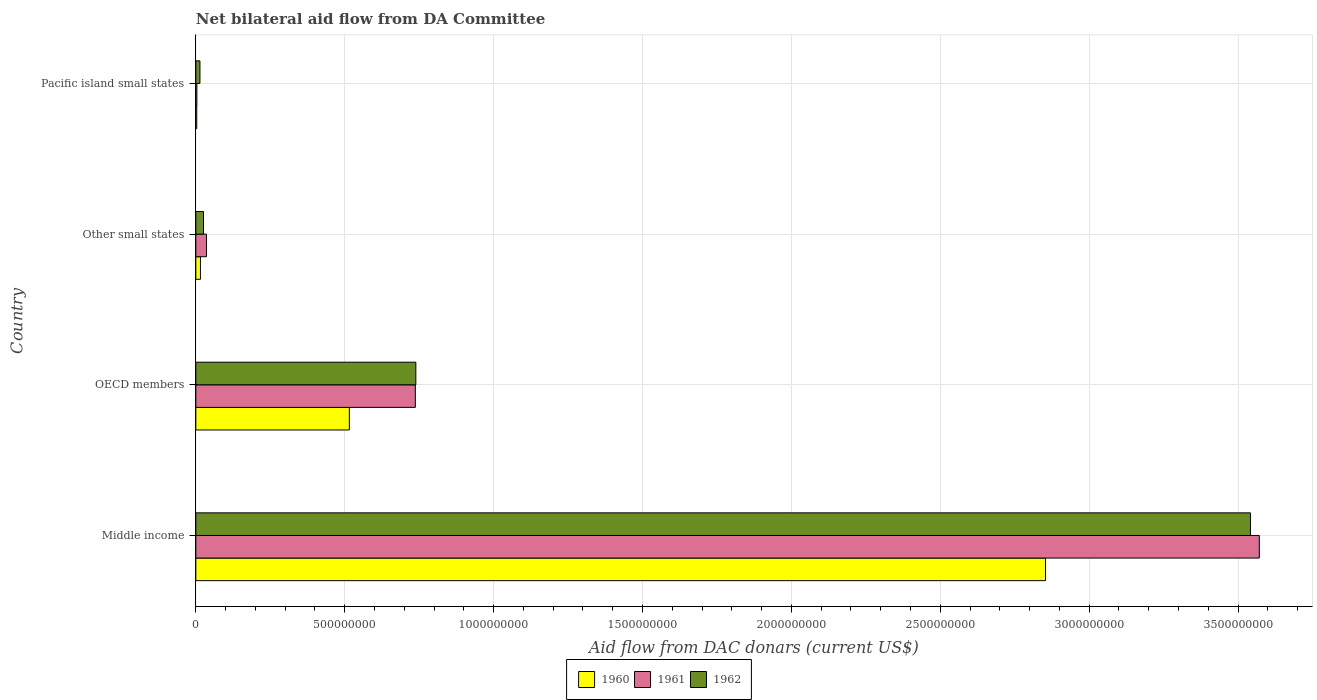How many bars are there on the 2nd tick from the top?
Make the answer very short. 3. How many bars are there on the 4th tick from the bottom?
Your response must be concise. 3. What is the label of the 2nd group of bars from the top?
Keep it short and to the point. Other small states. In how many cases, is the number of bars for a given country not equal to the number of legend labels?
Offer a terse response. 0. What is the aid flow in in 1960 in Middle income?
Offer a very short reply. 2.85e+09. Across all countries, what is the maximum aid flow in in 1960?
Provide a short and direct response. 2.85e+09. Across all countries, what is the minimum aid flow in in 1962?
Provide a short and direct response. 1.38e+07. In which country was the aid flow in in 1960 maximum?
Keep it short and to the point. Middle income. In which country was the aid flow in in 1961 minimum?
Make the answer very short. Pacific island small states. What is the total aid flow in in 1962 in the graph?
Give a very brief answer. 4.32e+09. What is the difference between the aid flow in in 1960 in Other small states and that in Pacific island small states?
Make the answer very short. 1.24e+07. What is the difference between the aid flow in in 1960 in Pacific island small states and the aid flow in in 1961 in Other small states?
Keep it short and to the point. -3.26e+07. What is the average aid flow in in 1961 per country?
Ensure brevity in your answer.  1.09e+09. What is the difference between the aid flow in in 1962 and aid flow in in 1961 in OECD members?
Give a very brief answer. 1.69e+06. What is the ratio of the aid flow in in 1962 in Middle income to that in OECD members?
Offer a terse response. 4.79. Is the aid flow in in 1960 in Other small states less than that in Pacific island small states?
Keep it short and to the point. No. What is the difference between the highest and the second highest aid flow in in 1962?
Offer a terse response. 2.80e+09. What is the difference between the highest and the lowest aid flow in in 1961?
Ensure brevity in your answer.  3.57e+09. In how many countries, is the aid flow in in 1960 greater than the average aid flow in in 1960 taken over all countries?
Your answer should be compact. 1. What does the 1st bar from the top in Middle income represents?
Your response must be concise. 1962. Is it the case that in every country, the sum of the aid flow in in 1962 and aid flow in in 1961 is greater than the aid flow in in 1960?
Ensure brevity in your answer.  Yes. How many bars are there?
Keep it short and to the point. 12. How many countries are there in the graph?
Offer a very short reply. 4. What is the difference between two consecutive major ticks on the X-axis?
Give a very brief answer. 5.00e+08. Does the graph contain any zero values?
Your answer should be compact. No. Where does the legend appear in the graph?
Keep it short and to the point. Bottom center. How many legend labels are there?
Ensure brevity in your answer.  3. What is the title of the graph?
Your answer should be very brief. Net bilateral aid flow from DA Committee. Does "2005" appear as one of the legend labels in the graph?
Your response must be concise. No. What is the label or title of the X-axis?
Provide a succinct answer. Aid flow from DAC donars (current US$). What is the label or title of the Y-axis?
Your answer should be compact. Country. What is the Aid flow from DAC donars (current US$) of 1960 in Middle income?
Your answer should be very brief. 2.85e+09. What is the Aid flow from DAC donars (current US$) in 1961 in Middle income?
Your answer should be very brief. 3.57e+09. What is the Aid flow from DAC donars (current US$) in 1962 in Middle income?
Provide a succinct answer. 3.54e+09. What is the Aid flow from DAC donars (current US$) of 1960 in OECD members?
Ensure brevity in your answer.  5.16e+08. What is the Aid flow from DAC donars (current US$) in 1961 in OECD members?
Your response must be concise. 7.37e+08. What is the Aid flow from DAC donars (current US$) in 1962 in OECD members?
Provide a succinct answer. 7.39e+08. What is the Aid flow from DAC donars (current US$) in 1960 in Other small states?
Give a very brief answer. 1.55e+07. What is the Aid flow from DAC donars (current US$) of 1961 in Other small states?
Offer a very short reply. 3.57e+07. What is the Aid flow from DAC donars (current US$) of 1962 in Other small states?
Offer a terse response. 2.57e+07. What is the Aid flow from DAC donars (current US$) of 1960 in Pacific island small states?
Offer a terse response. 3.08e+06. What is the Aid flow from DAC donars (current US$) of 1961 in Pacific island small states?
Your answer should be very brief. 3.47e+06. What is the Aid flow from DAC donars (current US$) in 1962 in Pacific island small states?
Provide a short and direct response. 1.38e+07. Across all countries, what is the maximum Aid flow from DAC donars (current US$) of 1960?
Ensure brevity in your answer.  2.85e+09. Across all countries, what is the maximum Aid flow from DAC donars (current US$) of 1961?
Offer a terse response. 3.57e+09. Across all countries, what is the maximum Aid flow from DAC donars (current US$) of 1962?
Your answer should be compact. 3.54e+09. Across all countries, what is the minimum Aid flow from DAC donars (current US$) in 1960?
Give a very brief answer. 3.08e+06. Across all countries, what is the minimum Aid flow from DAC donars (current US$) of 1961?
Make the answer very short. 3.47e+06. Across all countries, what is the minimum Aid flow from DAC donars (current US$) in 1962?
Your answer should be compact. 1.38e+07. What is the total Aid flow from DAC donars (current US$) of 1960 in the graph?
Provide a succinct answer. 3.39e+09. What is the total Aid flow from DAC donars (current US$) of 1961 in the graph?
Make the answer very short. 4.35e+09. What is the total Aid flow from DAC donars (current US$) of 1962 in the graph?
Your response must be concise. 4.32e+09. What is the difference between the Aid flow from DAC donars (current US$) in 1960 in Middle income and that in OECD members?
Give a very brief answer. 2.34e+09. What is the difference between the Aid flow from DAC donars (current US$) of 1961 in Middle income and that in OECD members?
Offer a very short reply. 2.83e+09. What is the difference between the Aid flow from DAC donars (current US$) in 1962 in Middle income and that in OECD members?
Give a very brief answer. 2.80e+09. What is the difference between the Aid flow from DAC donars (current US$) of 1960 in Middle income and that in Other small states?
Make the answer very short. 2.84e+09. What is the difference between the Aid flow from DAC donars (current US$) in 1961 in Middle income and that in Other small states?
Provide a short and direct response. 3.54e+09. What is the difference between the Aid flow from DAC donars (current US$) of 1962 in Middle income and that in Other small states?
Your answer should be very brief. 3.52e+09. What is the difference between the Aid flow from DAC donars (current US$) of 1960 in Middle income and that in Pacific island small states?
Give a very brief answer. 2.85e+09. What is the difference between the Aid flow from DAC donars (current US$) of 1961 in Middle income and that in Pacific island small states?
Keep it short and to the point. 3.57e+09. What is the difference between the Aid flow from DAC donars (current US$) of 1962 in Middle income and that in Pacific island small states?
Make the answer very short. 3.53e+09. What is the difference between the Aid flow from DAC donars (current US$) in 1960 in OECD members and that in Other small states?
Ensure brevity in your answer.  5.00e+08. What is the difference between the Aid flow from DAC donars (current US$) in 1961 in OECD members and that in Other small states?
Give a very brief answer. 7.02e+08. What is the difference between the Aid flow from DAC donars (current US$) in 1962 in OECD members and that in Other small states?
Your response must be concise. 7.13e+08. What is the difference between the Aid flow from DAC donars (current US$) in 1960 in OECD members and that in Pacific island small states?
Provide a short and direct response. 5.12e+08. What is the difference between the Aid flow from DAC donars (current US$) of 1961 in OECD members and that in Pacific island small states?
Ensure brevity in your answer.  7.34e+08. What is the difference between the Aid flow from DAC donars (current US$) in 1962 in OECD members and that in Pacific island small states?
Offer a very short reply. 7.25e+08. What is the difference between the Aid flow from DAC donars (current US$) in 1960 in Other small states and that in Pacific island small states?
Your answer should be compact. 1.24e+07. What is the difference between the Aid flow from DAC donars (current US$) in 1961 in Other small states and that in Pacific island small states?
Your answer should be very brief. 3.22e+07. What is the difference between the Aid flow from DAC donars (current US$) of 1962 in Other small states and that in Pacific island small states?
Your answer should be very brief. 1.19e+07. What is the difference between the Aid flow from DAC donars (current US$) in 1960 in Middle income and the Aid flow from DAC donars (current US$) in 1961 in OECD members?
Make the answer very short. 2.12e+09. What is the difference between the Aid flow from DAC donars (current US$) in 1960 in Middle income and the Aid flow from DAC donars (current US$) in 1962 in OECD members?
Ensure brevity in your answer.  2.11e+09. What is the difference between the Aid flow from DAC donars (current US$) of 1961 in Middle income and the Aid flow from DAC donars (current US$) of 1962 in OECD members?
Your answer should be very brief. 2.83e+09. What is the difference between the Aid flow from DAC donars (current US$) in 1960 in Middle income and the Aid flow from DAC donars (current US$) in 1961 in Other small states?
Offer a terse response. 2.82e+09. What is the difference between the Aid flow from DAC donars (current US$) of 1960 in Middle income and the Aid flow from DAC donars (current US$) of 1962 in Other small states?
Offer a very short reply. 2.83e+09. What is the difference between the Aid flow from DAC donars (current US$) of 1961 in Middle income and the Aid flow from DAC donars (current US$) of 1962 in Other small states?
Offer a terse response. 3.55e+09. What is the difference between the Aid flow from DAC donars (current US$) of 1960 in Middle income and the Aid flow from DAC donars (current US$) of 1961 in Pacific island small states?
Ensure brevity in your answer.  2.85e+09. What is the difference between the Aid flow from DAC donars (current US$) in 1960 in Middle income and the Aid flow from DAC donars (current US$) in 1962 in Pacific island small states?
Provide a succinct answer. 2.84e+09. What is the difference between the Aid flow from DAC donars (current US$) of 1961 in Middle income and the Aid flow from DAC donars (current US$) of 1962 in Pacific island small states?
Give a very brief answer. 3.56e+09. What is the difference between the Aid flow from DAC donars (current US$) of 1960 in OECD members and the Aid flow from DAC donars (current US$) of 1961 in Other small states?
Keep it short and to the point. 4.80e+08. What is the difference between the Aid flow from DAC donars (current US$) of 1960 in OECD members and the Aid flow from DAC donars (current US$) of 1962 in Other small states?
Keep it short and to the point. 4.90e+08. What is the difference between the Aid flow from DAC donars (current US$) of 1961 in OECD members and the Aid flow from DAC donars (current US$) of 1962 in Other small states?
Give a very brief answer. 7.11e+08. What is the difference between the Aid flow from DAC donars (current US$) of 1960 in OECD members and the Aid flow from DAC donars (current US$) of 1961 in Pacific island small states?
Your answer should be compact. 5.12e+08. What is the difference between the Aid flow from DAC donars (current US$) in 1960 in OECD members and the Aid flow from DAC donars (current US$) in 1962 in Pacific island small states?
Your answer should be very brief. 5.02e+08. What is the difference between the Aid flow from DAC donars (current US$) of 1961 in OECD members and the Aid flow from DAC donars (current US$) of 1962 in Pacific island small states?
Make the answer very short. 7.23e+08. What is the difference between the Aid flow from DAC donars (current US$) in 1960 in Other small states and the Aid flow from DAC donars (current US$) in 1961 in Pacific island small states?
Keep it short and to the point. 1.20e+07. What is the difference between the Aid flow from DAC donars (current US$) in 1960 in Other small states and the Aid flow from DAC donars (current US$) in 1962 in Pacific island small states?
Give a very brief answer. 1.74e+06. What is the difference between the Aid flow from DAC donars (current US$) of 1961 in Other small states and the Aid flow from DAC donars (current US$) of 1962 in Pacific island small states?
Provide a succinct answer. 2.19e+07. What is the average Aid flow from DAC donars (current US$) of 1960 per country?
Your answer should be very brief. 8.47e+08. What is the average Aid flow from DAC donars (current US$) of 1961 per country?
Ensure brevity in your answer.  1.09e+09. What is the average Aid flow from DAC donars (current US$) in 1962 per country?
Your response must be concise. 1.08e+09. What is the difference between the Aid flow from DAC donars (current US$) of 1960 and Aid flow from DAC donars (current US$) of 1961 in Middle income?
Offer a very short reply. -7.18e+08. What is the difference between the Aid flow from DAC donars (current US$) of 1960 and Aid flow from DAC donars (current US$) of 1962 in Middle income?
Offer a very short reply. -6.88e+08. What is the difference between the Aid flow from DAC donars (current US$) of 1961 and Aid flow from DAC donars (current US$) of 1962 in Middle income?
Ensure brevity in your answer.  2.98e+07. What is the difference between the Aid flow from DAC donars (current US$) in 1960 and Aid flow from DAC donars (current US$) in 1961 in OECD members?
Provide a succinct answer. -2.22e+08. What is the difference between the Aid flow from DAC donars (current US$) in 1960 and Aid flow from DAC donars (current US$) in 1962 in OECD members?
Offer a terse response. -2.23e+08. What is the difference between the Aid flow from DAC donars (current US$) of 1961 and Aid flow from DAC donars (current US$) of 1962 in OECD members?
Offer a very short reply. -1.69e+06. What is the difference between the Aid flow from DAC donars (current US$) in 1960 and Aid flow from DAC donars (current US$) in 1961 in Other small states?
Your answer should be very brief. -2.02e+07. What is the difference between the Aid flow from DAC donars (current US$) of 1960 and Aid flow from DAC donars (current US$) of 1962 in Other small states?
Your answer should be very brief. -1.02e+07. What is the difference between the Aid flow from DAC donars (current US$) of 1961 and Aid flow from DAC donars (current US$) of 1962 in Other small states?
Offer a very short reply. 9.95e+06. What is the difference between the Aid flow from DAC donars (current US$) of 1960 and Aid flow from DAC donars (current US$) of 1961 in Pacific island small states?
Keep it short and to the point. -3.90e+05. What is the difference between the Aid flow from DAC donars (current US$) in 1960 and Aid flow from DAC donars (current US$) in 1962 in Pacific island small states?
Offer a terse response. -1.07e+07. What is the difference between the Aid flow from DAC donars (current US$) of 1961 and Aid flow from DAC donars (current US$) of 1962 in Pacific island small states?
Provide a short and direct response. -1.03e+07. What is the ratio of the Aid flow from DAC donars (current US$) in 1960 in Middle income to that in OECD members?
Ensure brevity in your answer.  5.53. What is the ratio of the Aid flow from DAC donars (current US$) in 1961 in Middle income to that in OECD members?
Provide a succinct answer. 4.84. What is the ratio of the Aid flow from DAC donars (current US$) in 1962 in Middle income to that in OECD members?
Ensure brevity in your answer.  4.79. What is the ratio of the Aid flow from DAC donars (current US$) of 1960 in Middle income to that in Other small states?
Your answer should be very brief. 183.86. What is the ratio of the Aid flow from DAC donars (current US$) of 1961 in Middle income to that in Other small states?
Provide a short and direct response. 100.13. What is the ratio of the Aid flow from DAC donars (current US$) of 1962 in Middle income to that in Other small states?
Keep it short and to the point. 137.7. What is the ratio of the Aid flow from DAC donars (current US$) in 1960 in Middle income to that in Pacific island small states?
Offer a very short reply. 926.44. What is the ratio of the Aid flow from DAC donars (current US$) in 1961 in Middle income to that in Pacific island small states?
Make the answer very short. 1029.27. What is the ratio of the Aid flow from DAC donars (current US$) in 1962 in Middle income to that in Pacific island small states?
Offer a terse response. 257.02. What is the ratio of the Aid flow from DAC donars (current US$) of 1960 in OECD members to that in Other small states?
Give a very brief answer. 33.22. What is the ratio of the Aid flow from DAC donars (current US$) of 1961 in OECD members to that in Other small states?
Offer a terse response. 20.67. What is the ratio of the Aid flow from DAC donars (current US$) of 1962 in OECD members to that in Other small states?
Keep it short and to the point. 28.73. What is the ratio of the Aid flow from DAC donars (current US$) of 1960 in OECD members to that in Pacific island small states?
Give a very brief answer. 167.39. What is the ratio of the Aid flow from DAC donars (current US$) of 1961 in OECD members to that in Pacific island small states?
Your answer should be very brief. 212.45. What is the ratio of the Aid flow from DAC donars (current US$) of 1962 in OECD members to that in Pacific island small states?
Your answer should be very brief. 53.62. What is the ratio of the Aid flow from DAC donars (current US$) of 1960 in Other small states to that in Pacific island small states?
Provide a succinct answer. 5.04. What is the ratio of the Aid flow from DAC donars (current US$) in 1961 in Other small states to that in Pacific island small states?
Your answer should be compact. 10.28. What is the ratio of the Aid flow from DAC donars (current US$) of 1962 in Other small states to that in Pacific island small states?
Provide a short and direct response. 1.87. What is the difference between the highest and the second highest Aid flow from DAC donars (current US$) in 1960?
Your response must be concise. 2.34e+09. What is the difference between the highest and the second highest Aid flow from DAC donars (current US$) of 1961?
Keep it short and to the point. 2.83e+09. What is the difference between the highest and the second highest Aid flow from DAC donars (current US$) in 1962?
Your answer should be compact. 2.80e+09. What is the difference between the highest and the lowest Aid flow from DAC donars (current US$) in 1960?
Your answer should be very brief. 2.85e+09. What is the difference between the highest and the lowest Aid flow from DAC donars (current US$) in 1961?
Offer a very short reply. 3.57e+09. What is the difference between the highest and the lowest Aid flow from DAC donars (current US$) in 1962?
Provide a succinct answer. 3.53e+09. 